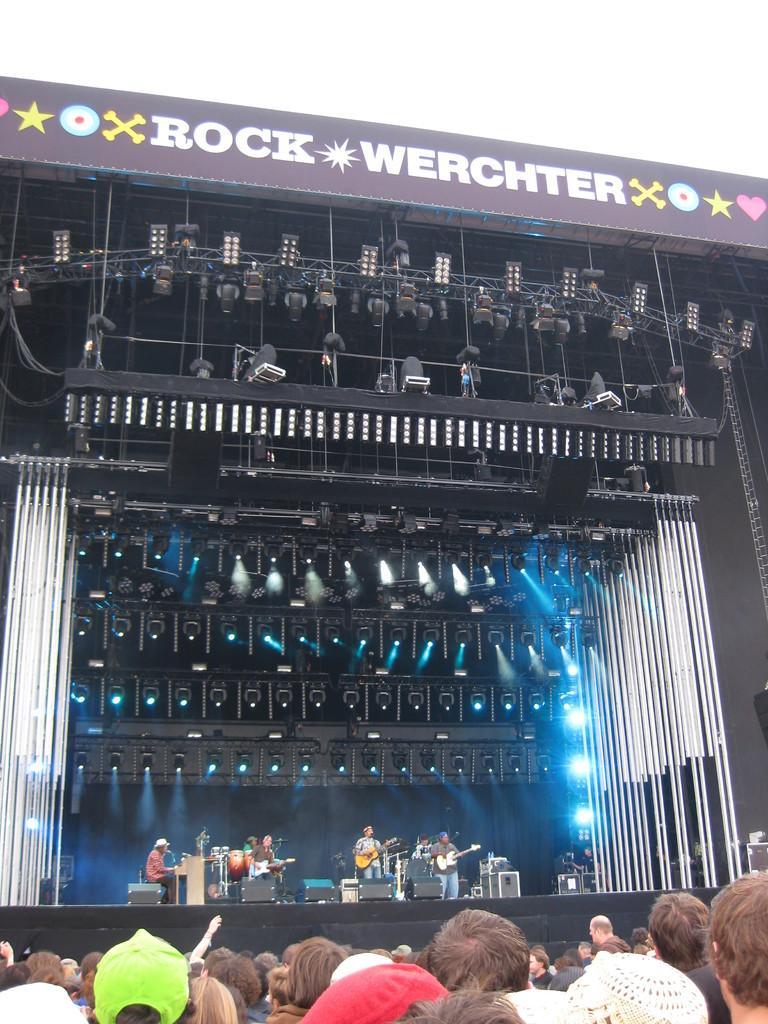How would you summarize this image in a sentence or two? A concert is going on. People are present. People are performing on the stage, playing musical instruments. There are lights and a board on the top. 